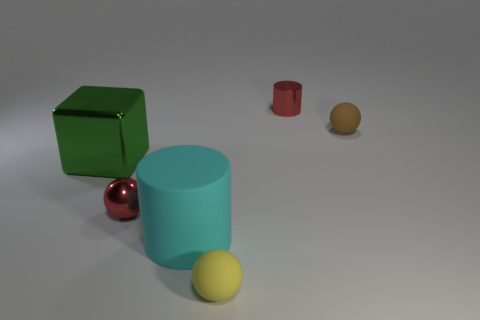Subtract all rubber balls. How many balls are left? 1 Add 1 large cubes. How many objects exist? 7 Subtract all cubes. How many objects are left? 5 Subtract all green balls. Subtract all blue cylinders. How many balls are left? 3 Add 3 large gray shiny cylinders. How many large gray shiny cylinders exist? 3 Subtract 0 red cubes. How many objects are left? 6 Subtract all large cyan rubber blocks. Subtract all metal objects. How many objects are left? 3 Add 4 small spheres. How many small spheres are left? 7 